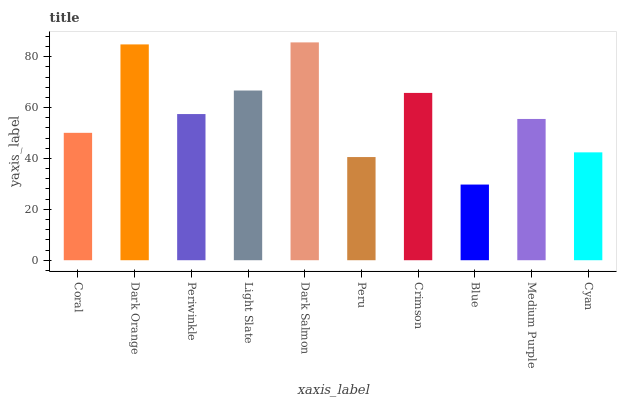Is Blue the minimum?
Answer yes or no. Yes. Is Dark Salmon the maximum?
Answer yes or no. Yes. Is Dark Orange the minimum?
Answer yes or no. No. Is Dark Orange the maximum?
Answer yes or no. No. Is Dark Orange greater than Coral?
Answer yes or no. Yes. Is Coral less than Dark Orange?
Answer yes or no. Yes. Is Coral greater than Dark Orange?
Answer yes or no. No. Is Dark Orange less than Coral?
Answer yes or no. No. Is Periwinkle the high median?
Answer yes or no. Yes. Is Medium Purple the low median?
Answer yes or no. Yes. Is Dark Salmon the high median?
Answer yes or no. No. Is Light Slate the low median?
Answer yes or no. No. 